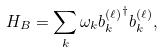<formula> <loc_0><loc_0><loc_500><loc_500>H _ { B } = \sum _ { k } \omega _ { k } { b _ { k } ^ { ( \ell ) } } ^ { \dag } b _ { k } ^ { ( \ell ) } ,</formula> 